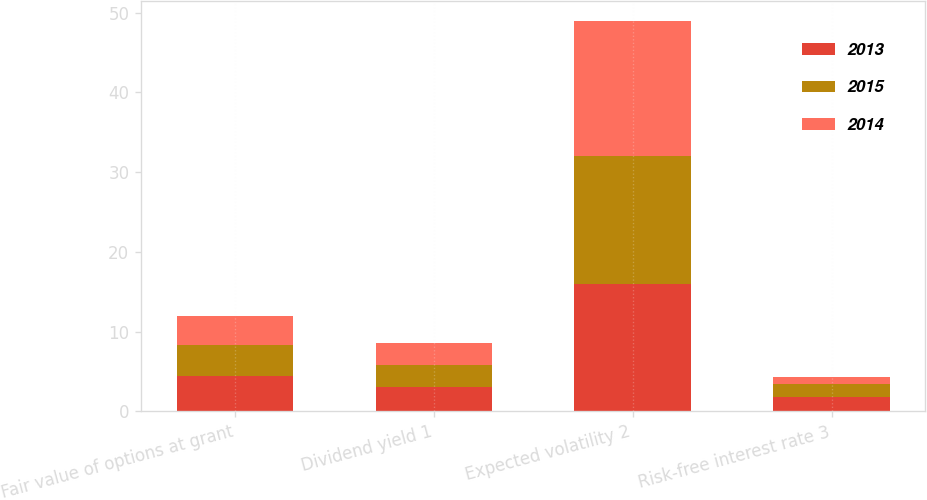<chart> <loc_0><loc_0><loc_500><loc_500><stacked_bar_chart><ecel><fcel>Fair value of options at grant<fcel>Dividend yield 1<fcel>Expected volatility 2<fcel>Risk-free interest rate 3<nl><fcel>2013<fcel>4.38<fcel>3.1<fcel>16<fcel>1.8<nl><fcel>2015<fcel>3.91<fcel>2.7<fcel>16<fcel>1.6<nl><fcel>2014<fcel>3.73<fcel>2.8<fcel>17<fcel>0.9<nl></chart> 